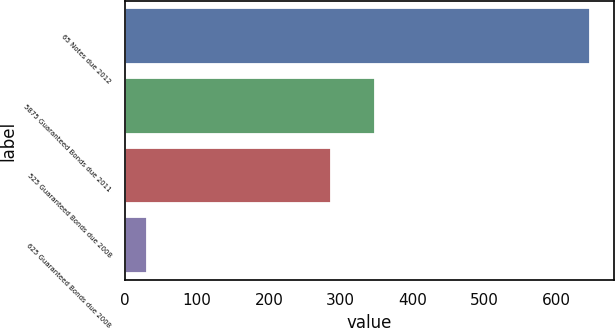Convert chart. <chart><loc_0><loc_0><loc_500><loc_500><bar_chart><fcel>65 Notes due 2012<fcel>5875 Guaranteed Bonds due 2011<fcel>525 Guaranteed Bonds due 2008<fcel>625 Guaranteed Bonds due 2008<nl><fcel>648<fcel>347.8<fcel>286<fcel>30<nl></chart> 